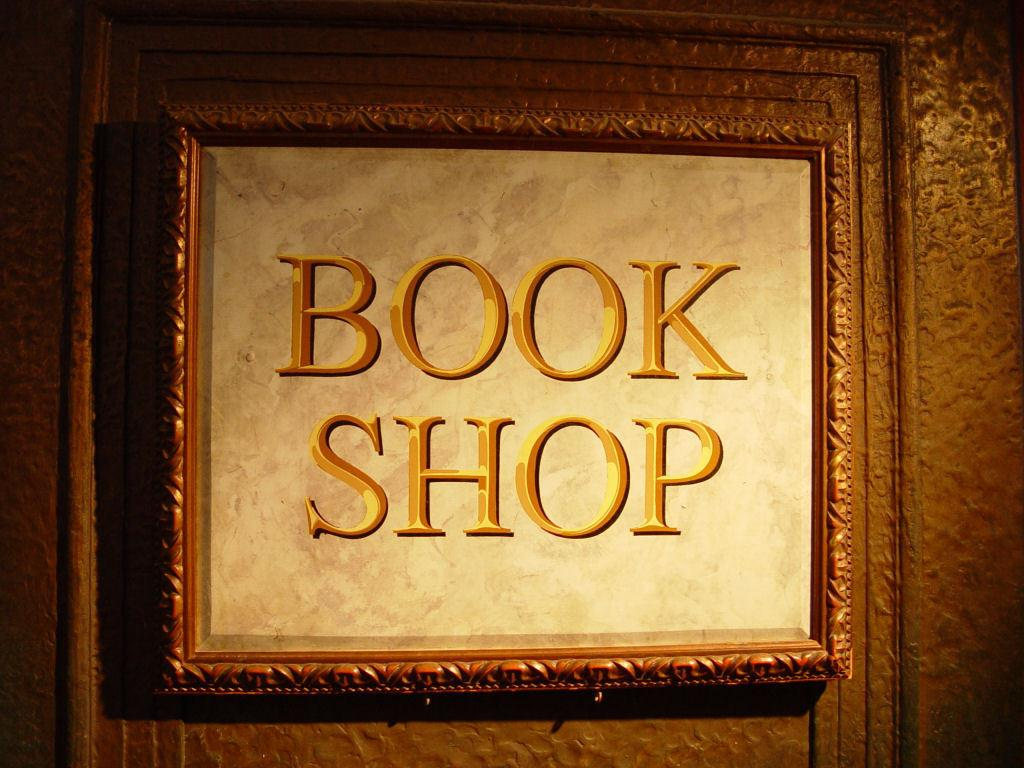<image>
Share a concise interpretation of the image provided. A sign with the name Book Shop framed in gold with gold lettering. 